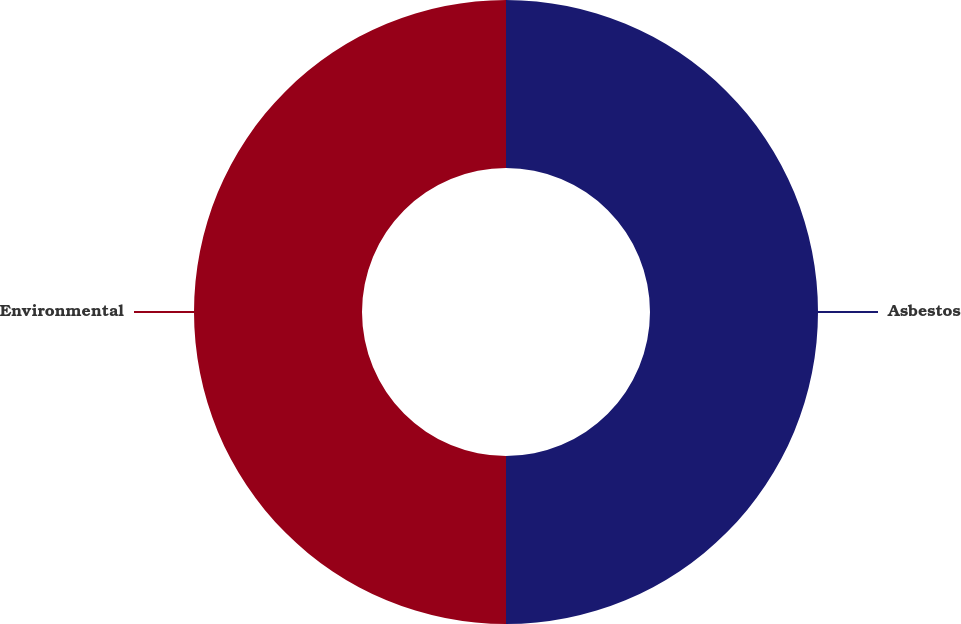Convert chart. <chart><loc_0><loc_0><loc_500><loc_500><pie_chart><fcel>Asbestos<fcel>Environmental<nl><fcel>50.0%<fcel>50.0%<nl></chart> 